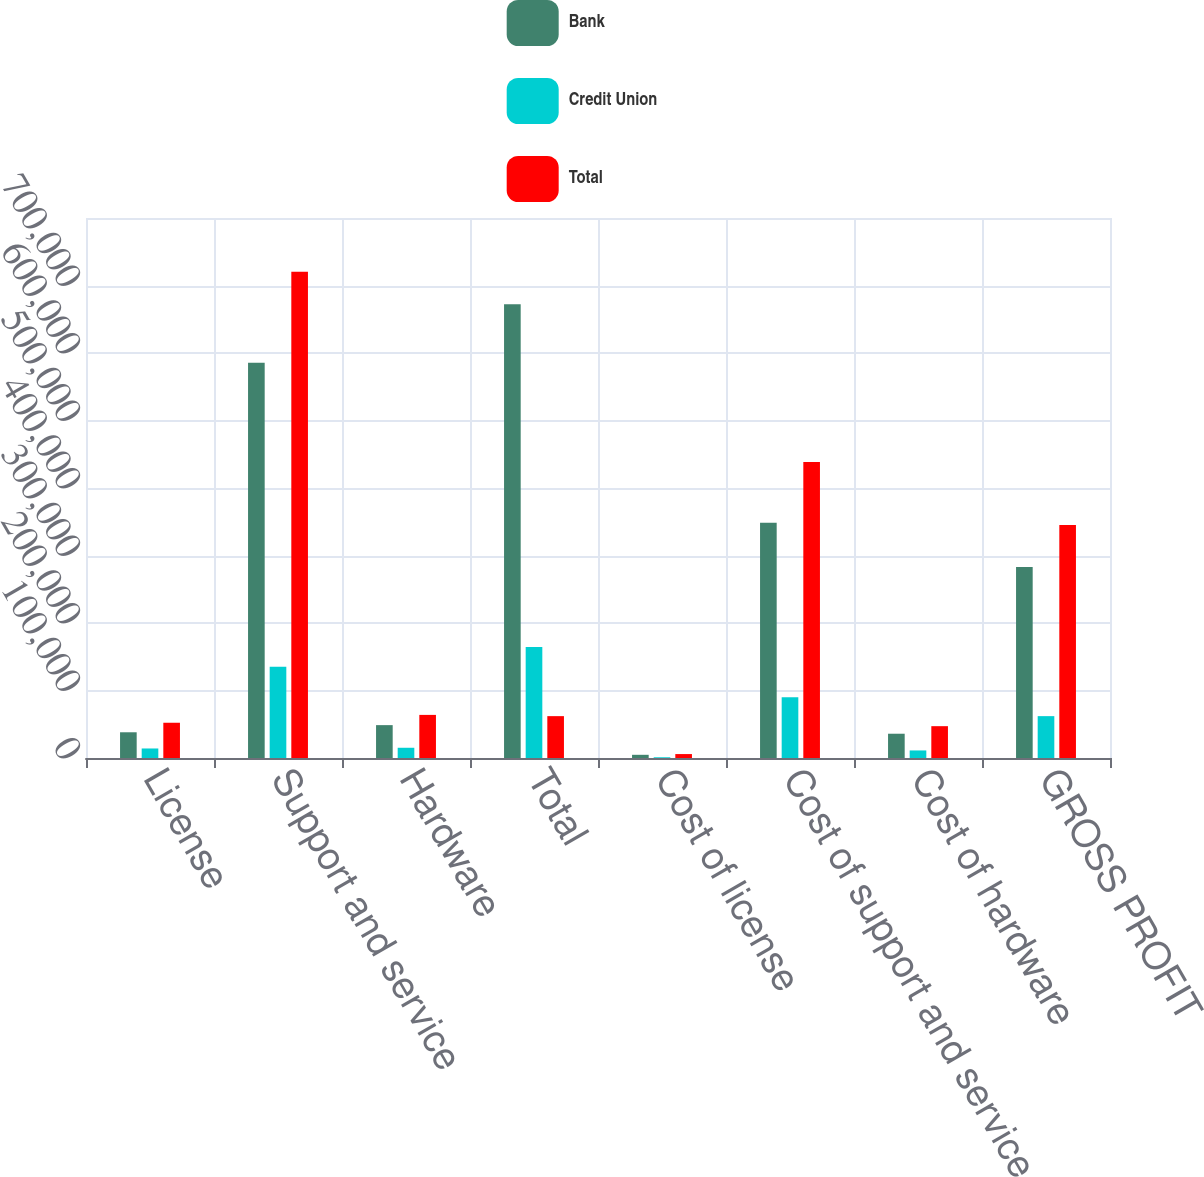Convert chart. <chart><loc_0><loc_0><loc_500><loc_500><stacked_bar_chart><ecel><fcel>License<fcel>Support and service<fcel>Hardware<fcel>Total<fcel>Cost of license<fcel>Cost of support and service<fcel>Cost of hardware<fcel>GROSS PROFIT<nl><fcel>Bank<fcel>38117<fcel>585470<fcel>48695<fcel>672282<fcel>4732<fcel>348489<fcel>35961<fcel>283100<nl><fcel>Credit Union<fcel>14108<fcel>135034<fcel>15162<fcel>164304<fcel>1095<fcel>89987<fcel>11202<fcel>62020<nl><fcel>Total<fcel>52225<fcel>720504<fcel>63857<fcel>62020<fcel>5827<fcel>438476<fcel>47163<fcel>345120<nl></chart> 